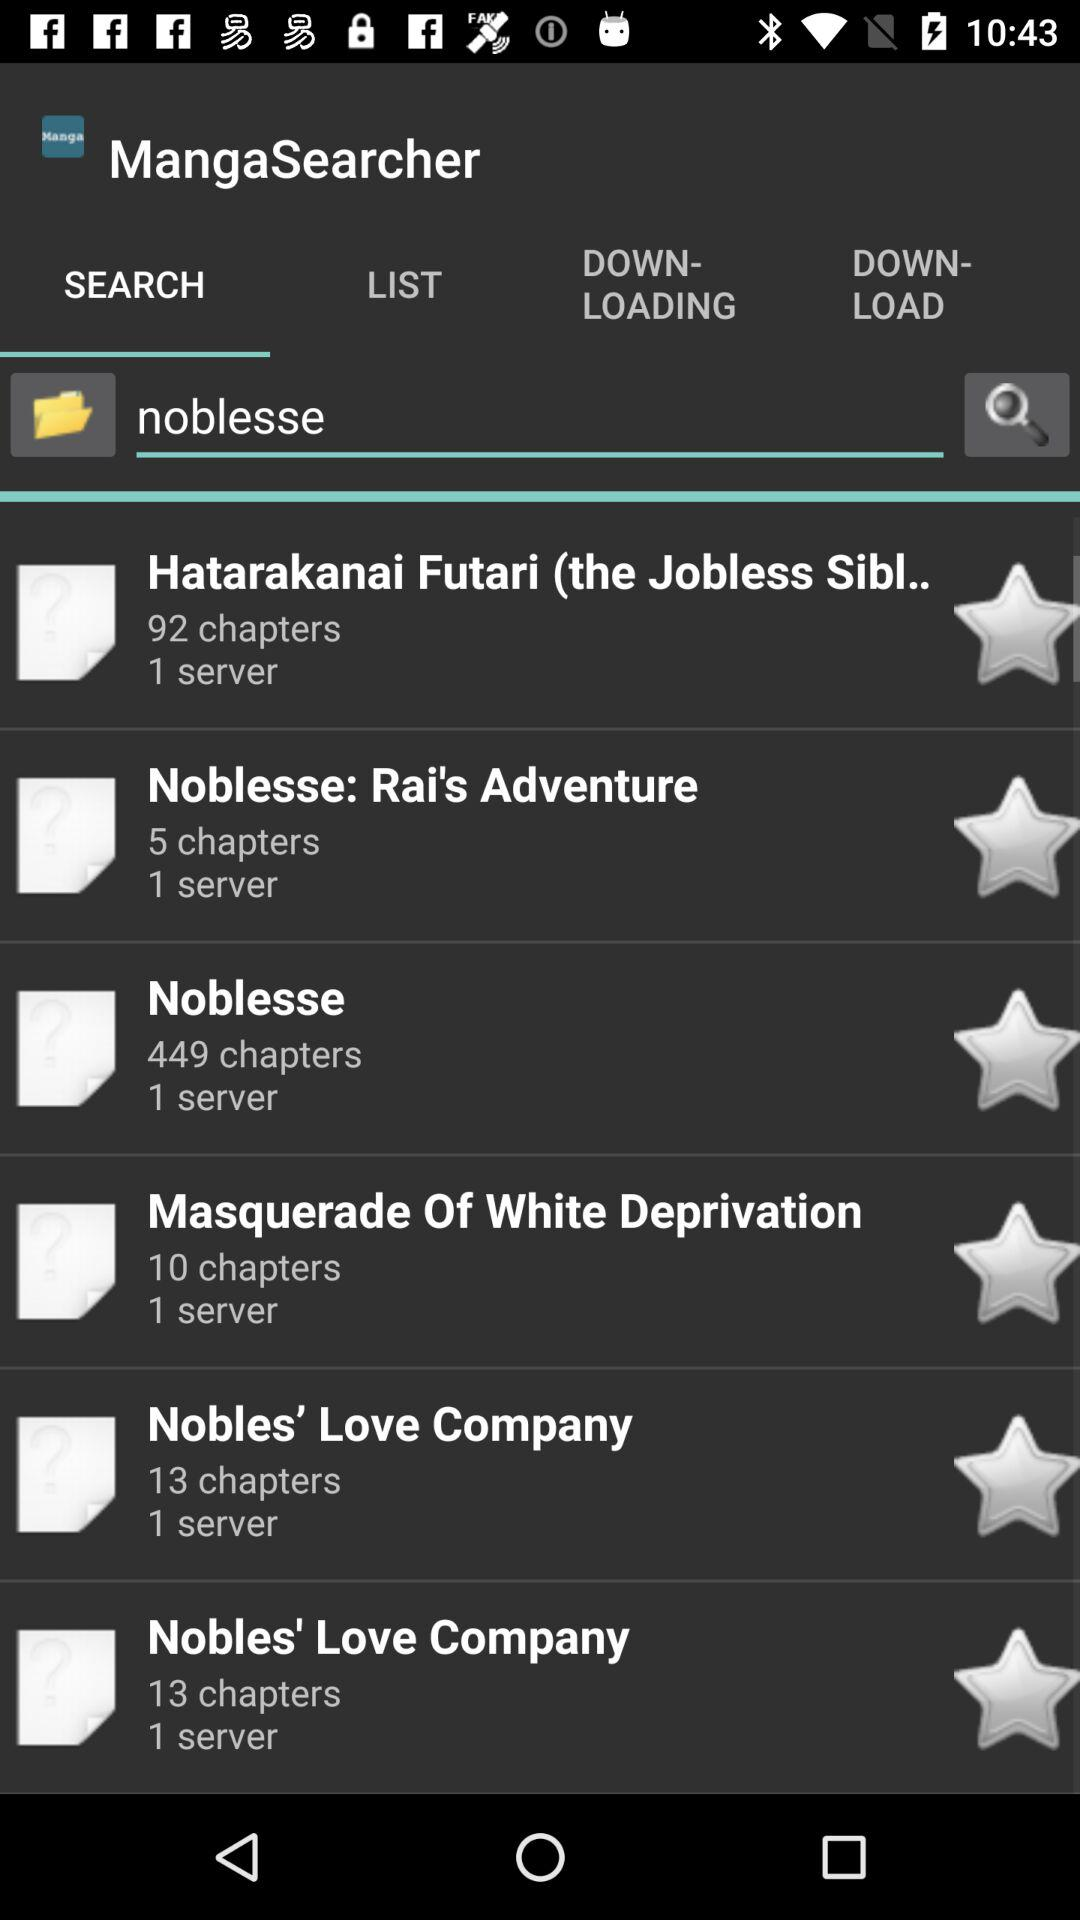With how many servers is the "Nobles' Love Company" connected? It is connected to 1 server. 